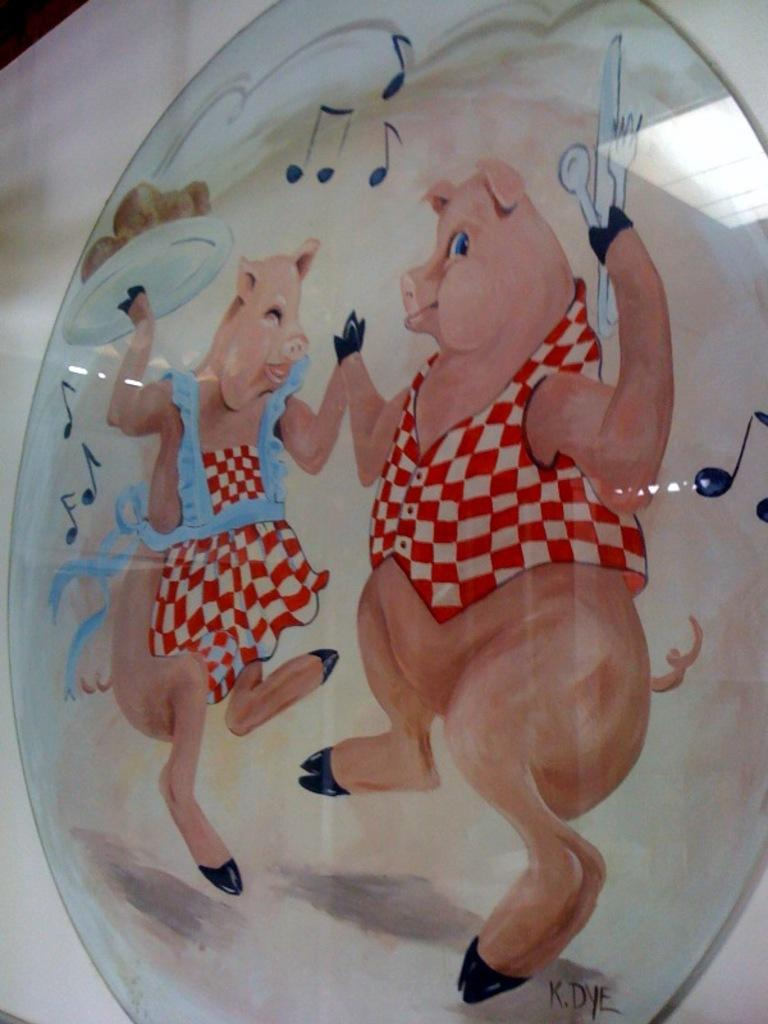What is the main subject of the image? There is a picture in the image. What animals are depicted in the picture? The picture contains two pigs. What are the pigs doing in the picture? One pig is carrying a serving plate in its hand, and the other pig is holding cutlery in its hand. Can you see the pigs swimming in the zoo in the image? There is no zoo or swimming pigs present in the image; it features two pigs holding a serving plate and cutlery. Are the pigs in the image exploring space? There is no indication of space or space exploration in the image; it features two pigs holding a serving plate and cutlery. 